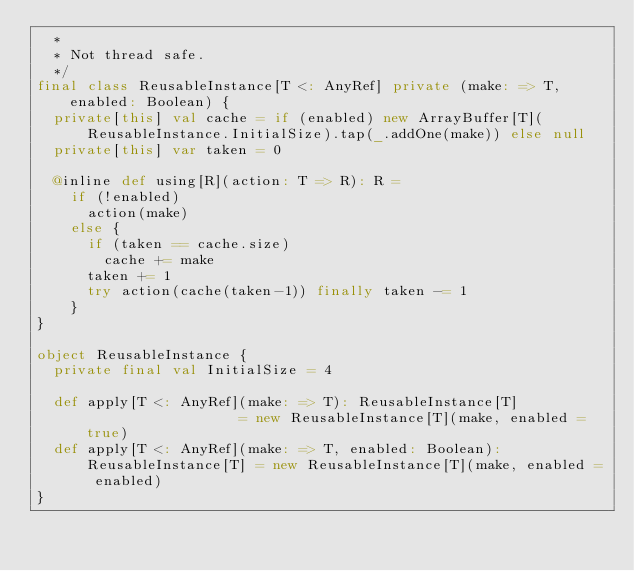<code> <loc_0><loc_0><loc_500><loc_500><_Scala_>  *
  * Not thread safe.
  */
final class ReusableInstance[T <: AnyRef] private (make: => T, enabled: Boolean) {
  private[this] val cache = if (enabled) new ArrayBuffer[T](ReusableInstance.InitialSize).tap(_.addOne(make)) else null
  private[this] var taken = 0

  @inline def using[R](action: T => R): R =
    if (!enabled)
      action(make)
    else {
      if (taken == cache.size)
        cache += make
      taken += 1
      try action(cache(taken-1)) finally taken -= 1
    }
}

object ReusableInstance {
  private final val InitialSize = 4

  def apply[T <: AnyRef](make: => T): ReusableInstance[T]                   = new ReusableInstance[T](make, enabled = true)
  def apply[T <: AnyRef](make: => T, enabled: Boolean): ReusableInstance[T] = new ReusableInstance[T](make, enabled = enabled)
}
</code> 